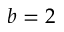<formula> <loc_0><loc_0><loc_500><loc_500>b = 2</formula> 